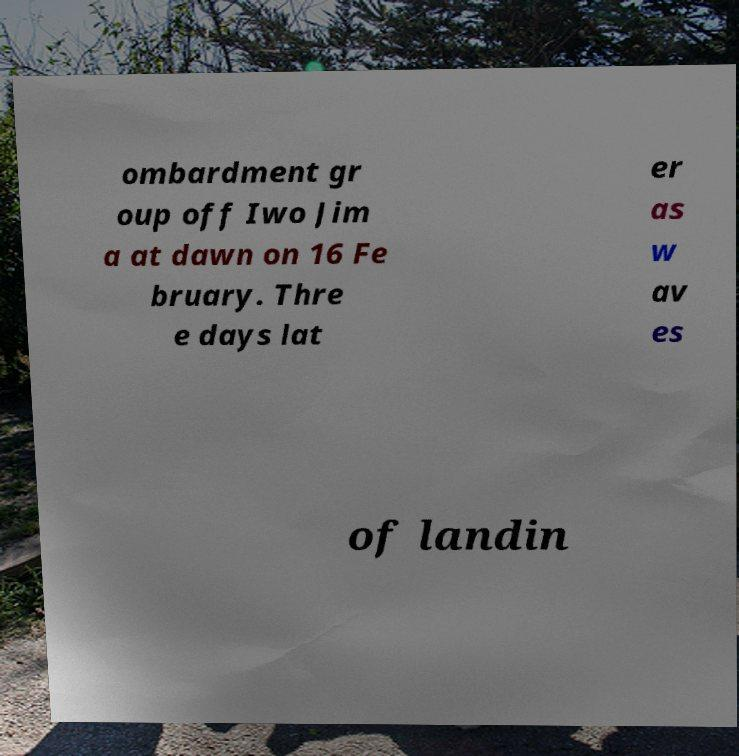Could you extract and type out the text from this image? ombardment gr oup off Iwo Jim a at dawn on 16 Fe bruary. Thre e days lat er as w av es of landin 